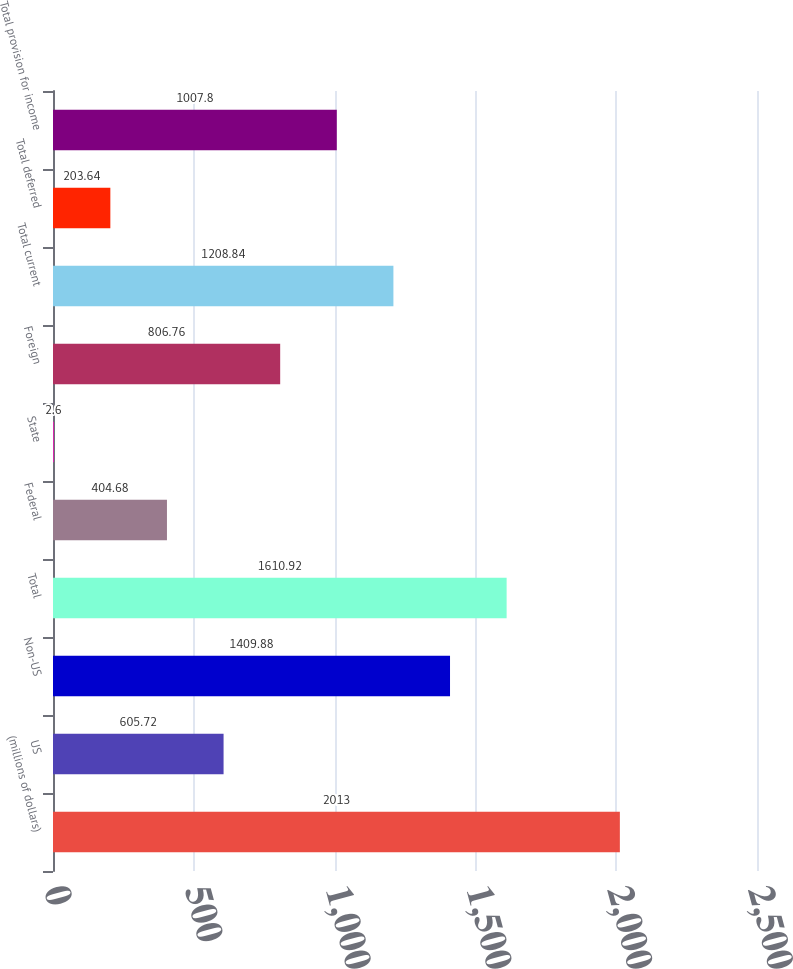<chart> <loc_0><loc_0><loc_500><loc_500><bar_chart><fcel>(millions of dollars)<fcel>US<fcel>Non-US<fcel>Total<fcel>Federal<fcel>State<fcel>Foreign<fcel>Total current<fcel>Total deferred<fcel>Total provision for income<nl><fcel>2013<fcel>605.72<fcel>1409.88<fcel>1610.92<fcel>404.68<fcel>2.6<fcel>806.76<fcel>1208.84<fcel>203.64<fcel>1007.8<nl></chart> 